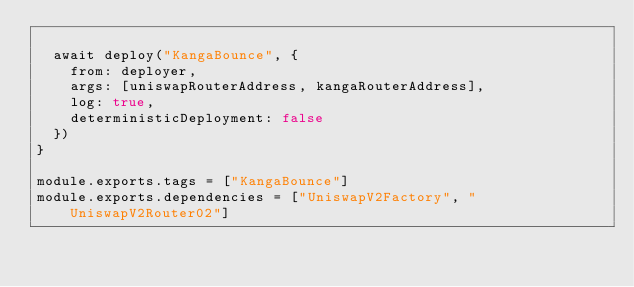<code> <loc_0><loc_0><loc_500><loc_500><_JavaScript_>
  await deploy("KangaBounce", {
    from: deployer,
    args: [uniswapRouterAddress, kangaRouterAddress],
    log: true,
    deterministicDeployment: false
  })
}

module.exports.tags = ["KangaBounce"]
module.exports.dependencies = ["UniswapV2Factory", "UniswapV2Router02"]
</code> 